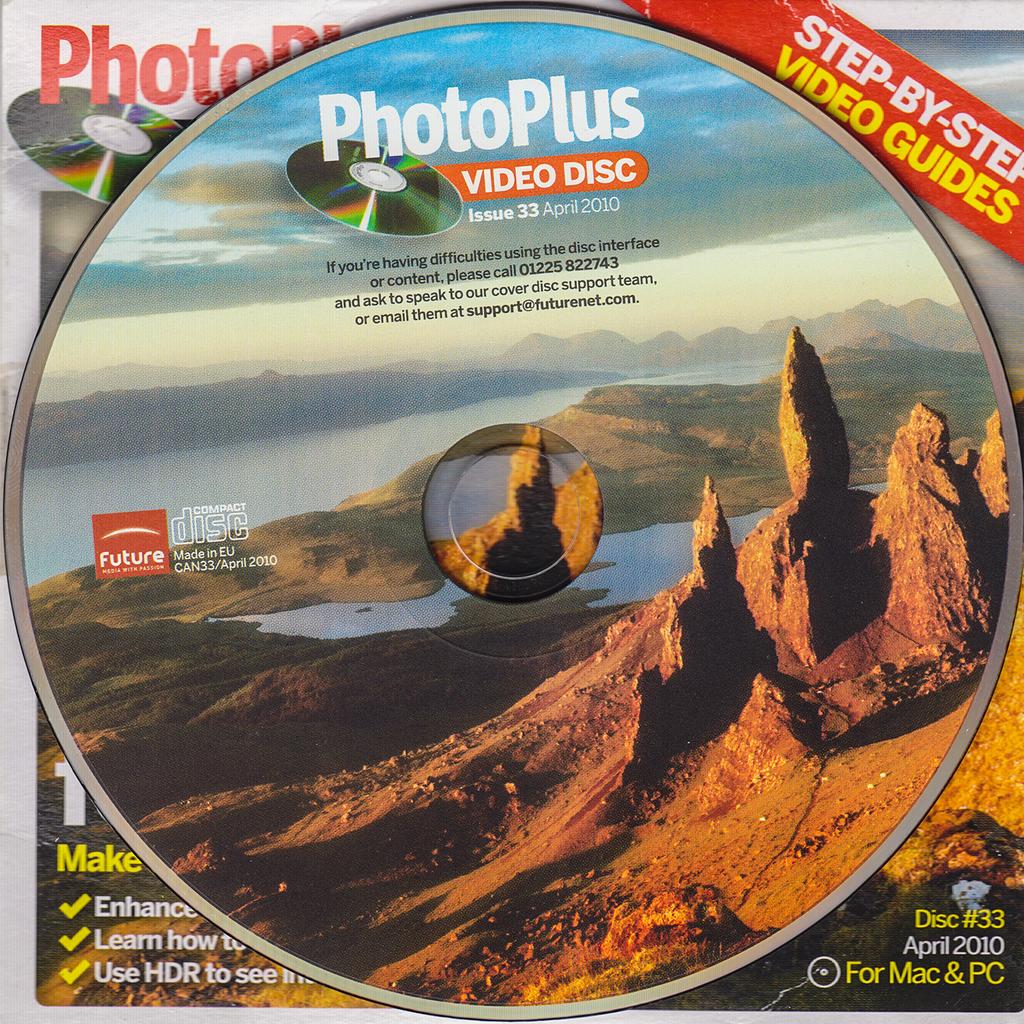What is this cd used for?
Your answer should be compact. Photos. What year was this disk made?
Provide a short and direct response. 2010. 